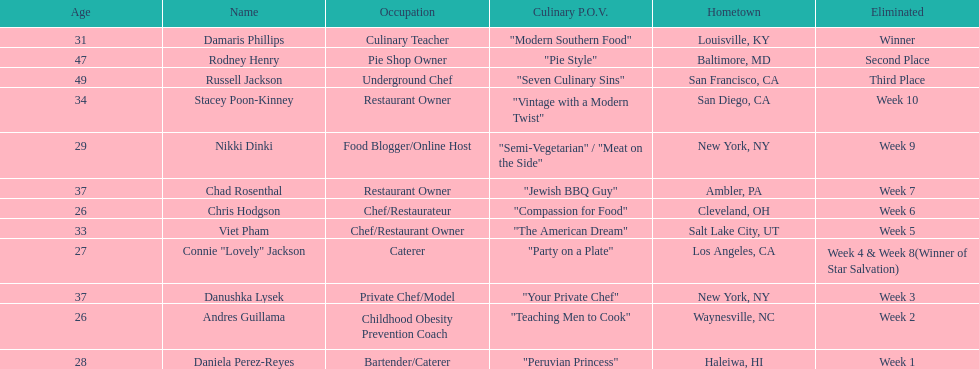Who was ousted initially, nikki dinki or viet pham? Viet Pham. 